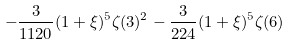Convert formula to latex. <formula><loc_0><loc_0><loc_500><loc_500>- \frac { 3 } { 1 1 2 0 } ( 1 + \xi ) ^ { 5 } \zeta ( 3 ) ^ { 2 } - \frac { 3 } { 2 2 4 } ( 1 + \xi ) ^ { 5 } \zeta ( 6 )</formula> 